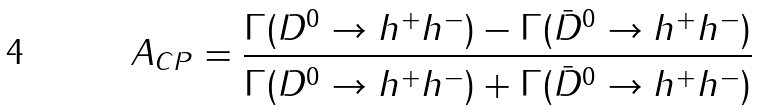<formula> <loc_0><loc_0><loc_500><loc_500>A _ { C P } = \frac { \Gamma ( D ^ { 0 } \to h ^ { + } h ^ { - } ) - \Gamma ( \bar { D } ^ { 0 } \to h ^ { + } h ^ { - } ) } { \Gamma ( D ^ { 0 } \to h ^ { + } h ^ { - } ) + \Gamma ( \bar { D } ^ { 0 } \to h ^ { + } h ^ { - } ) }</formula> 